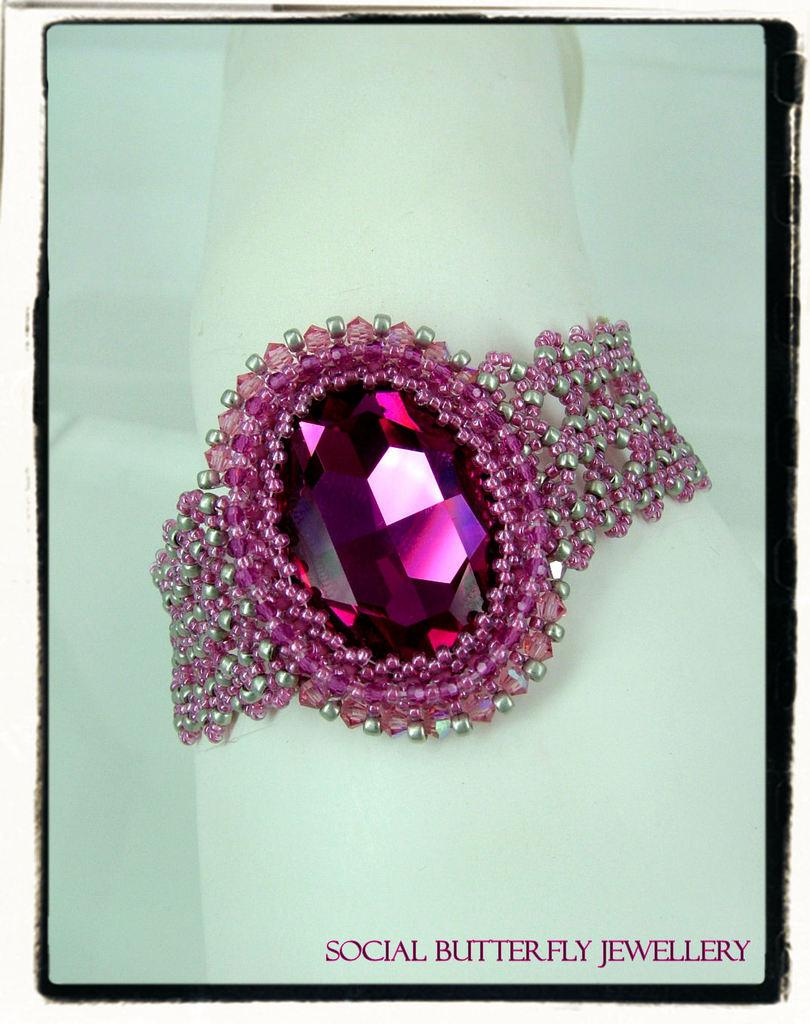What is the main object in the picture? There is an ornament in the picture. What is the color of the stone in the middle of the ornament? The stone in the middle of the ornament has a pink color. What can be seen in the background of the picture? There is a paper in the background of the picture. What is written or visible at the bottom of the paper? There is text visible at the bottom of the paper. What type of dinner is being served by the fireman in the image? There is no fireman or dinner present in the image; it features an ornament with a pink stone and a paper with text. How does the ornament maintain its balance in the image? The ornament does not need to maintain its balance in the image, as it is stationary and not in motion. 